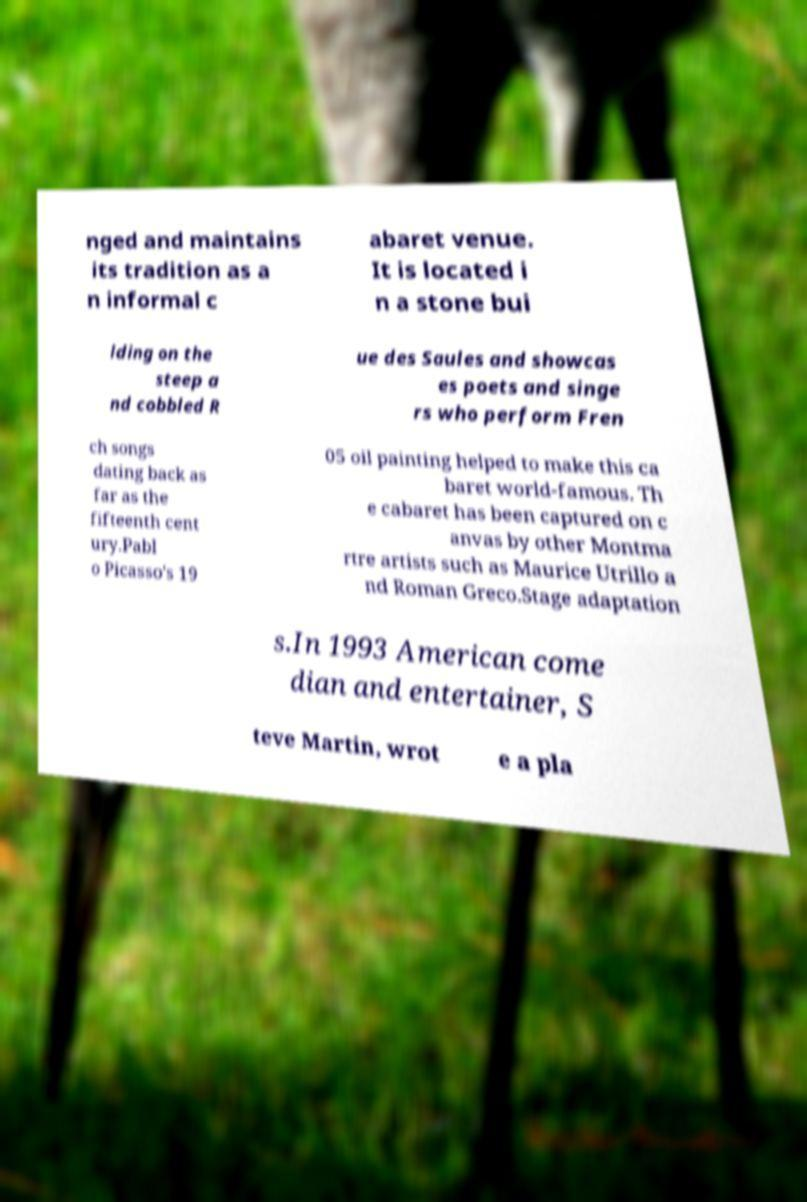Can you accurately transcribe the text from the provided image for me? nged and maintains its tradition as a n informal c abaret venue. It is located i n a stone bui lding on the steep a nd cobbled R ue des Saules and showcas es poets and singe rs who perform Fren ch songs dating back as far as the fifteenth cent ury.Pabl o Picasso's 19 05 oil painting helped to make this ca baret world-famous. Th e cabaret has been captured on c anvas by other Montma rtre artists such as Maurice Utrillo a nd Roman Greco.Stage adaptation s.In 1993 American come dian and entertainer, S teve Martin, wrot e a pla 